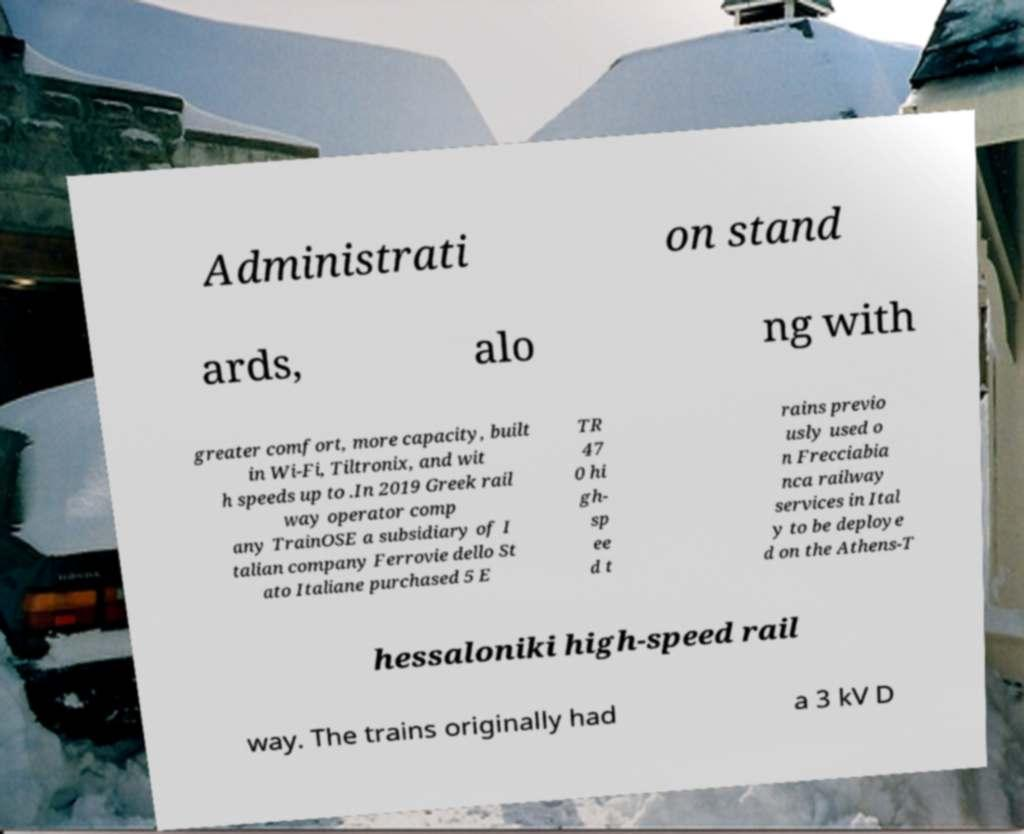I need the written content from this picture converted into text. Can you do that? Administrati on stand ards, alo ng with greater comfort, more capacity, built in Wi-Fi, Tiltronix, and wit h speeds up to .In 2019 Greek rail way operator comp any TrainOSE a subsidiary of I talian company Ferrovie dello St ato Italiane purchased 5 E TR 47 0 hi gh- sp ee d t rains previo usly used o n Frecciabia nca railway services in Ital y to be deploye d on the Athens-T hessaloniki high-speed rail way. The trains originally had a 3 kV D 